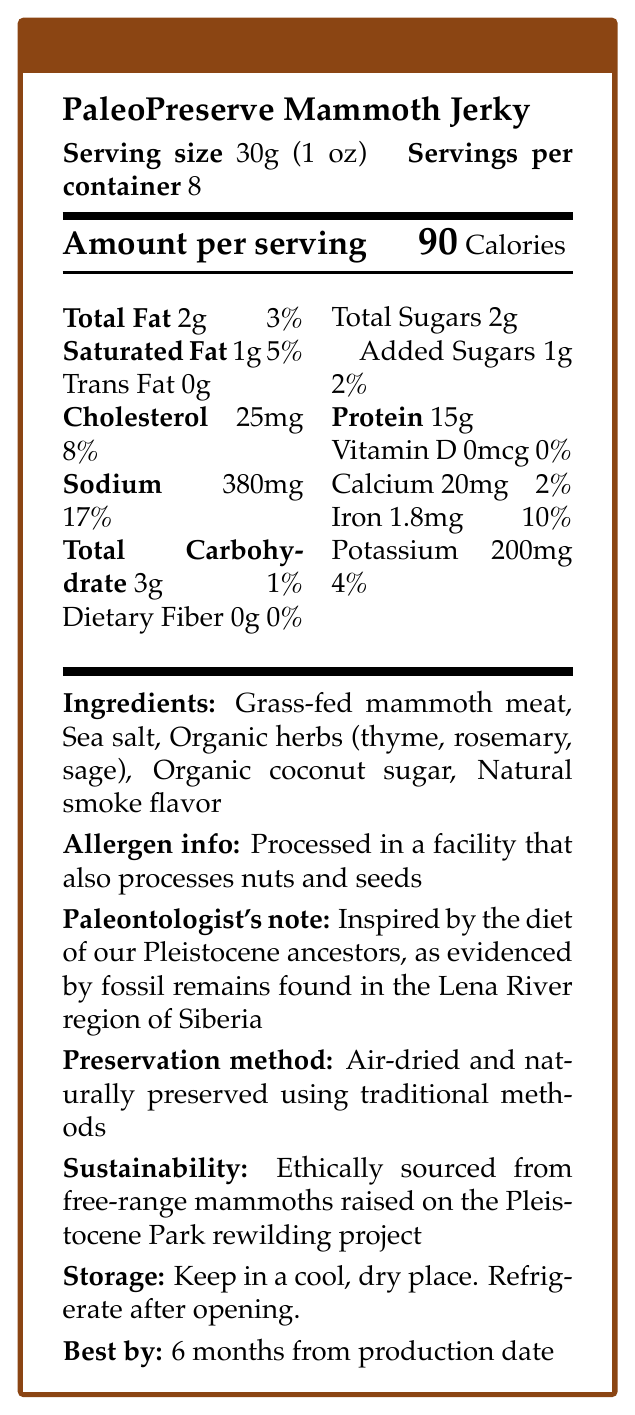How many ounces are in one serving of PaleoPreserve Mammoth Jerky? According to the document, the serving size of PaleoPreserve Mammoth Jerky is 30g, which is equivalent to 1 oz.
Answer: 1 oz What is the calorie count per serving of PaleoPreserve Mammoth Jerky? The document states that the amount per serving is 90 calories.
Answer: 90 calories How much protein is included in a single serving of the jerky? The Nutrition Facts label specifies that there are 15g of protein per serving.
Answer: 15g What percentage of the daily value for sodium does one serving of this product provide? The document shows that one serving contains 380mg of sodium, which is 17% of the daily value.
Answer: 17% Which types of fat are found in PaleoPreserve Mammoth Jerky and in what amounts? The label lists 2g of total fat, 1g of saturated fat, and 0g of trans fat per serving.
Answer: 2g total fat, 1g saturated fat, 0g trans fat Based on the ingredients list, which of the following is not an ingredient in the jerky? A. Sea salt B. Thyme C. Honey D. Organic coconut sugar The ingredients list includes sea salt, thyme, and organic coconut sugar, but does not mention honey.
Answer: C. Honey What is the daily value percentage for iron in one serving of this product? A. 2% B. 4% C. 10% D. 17% The document indicates there is 1.8mg of iron per serving, which is 10% of the daily value.
Answer: C. 10% Does the PaleoPreserve Mammoth Jerky contain dietary fiber? The Nutrition Facts label shows that there is 0g of dietary fiber in the product.
Answer: No Is this product processed in a facility that also handles nuts and seeds? The allergen information clearly states that the product is processed in a facility that also processes nuts and seeds.
Answer: Yes Summarize the main idea of the document. This summary captures the various sections of the document, including nutritional information, ingredients, and additional notes like allergen information and sustainability practices.
Answer: The document provides a detailed Nutrition Facts label for PaleoPreserve Mammoth Jerky, indicating serving sizes, calories, macronutrients, micronutrients, ingredients, allergen information, preservation methods, sustainability, and storage instructions. What is the address of the Pleistocene Park rewilding project? The document mentions that the mammoths are sourced from the Pleistocene Park rewilding project but does not provide an address or specific location details.
Answer: Cannot be determined 